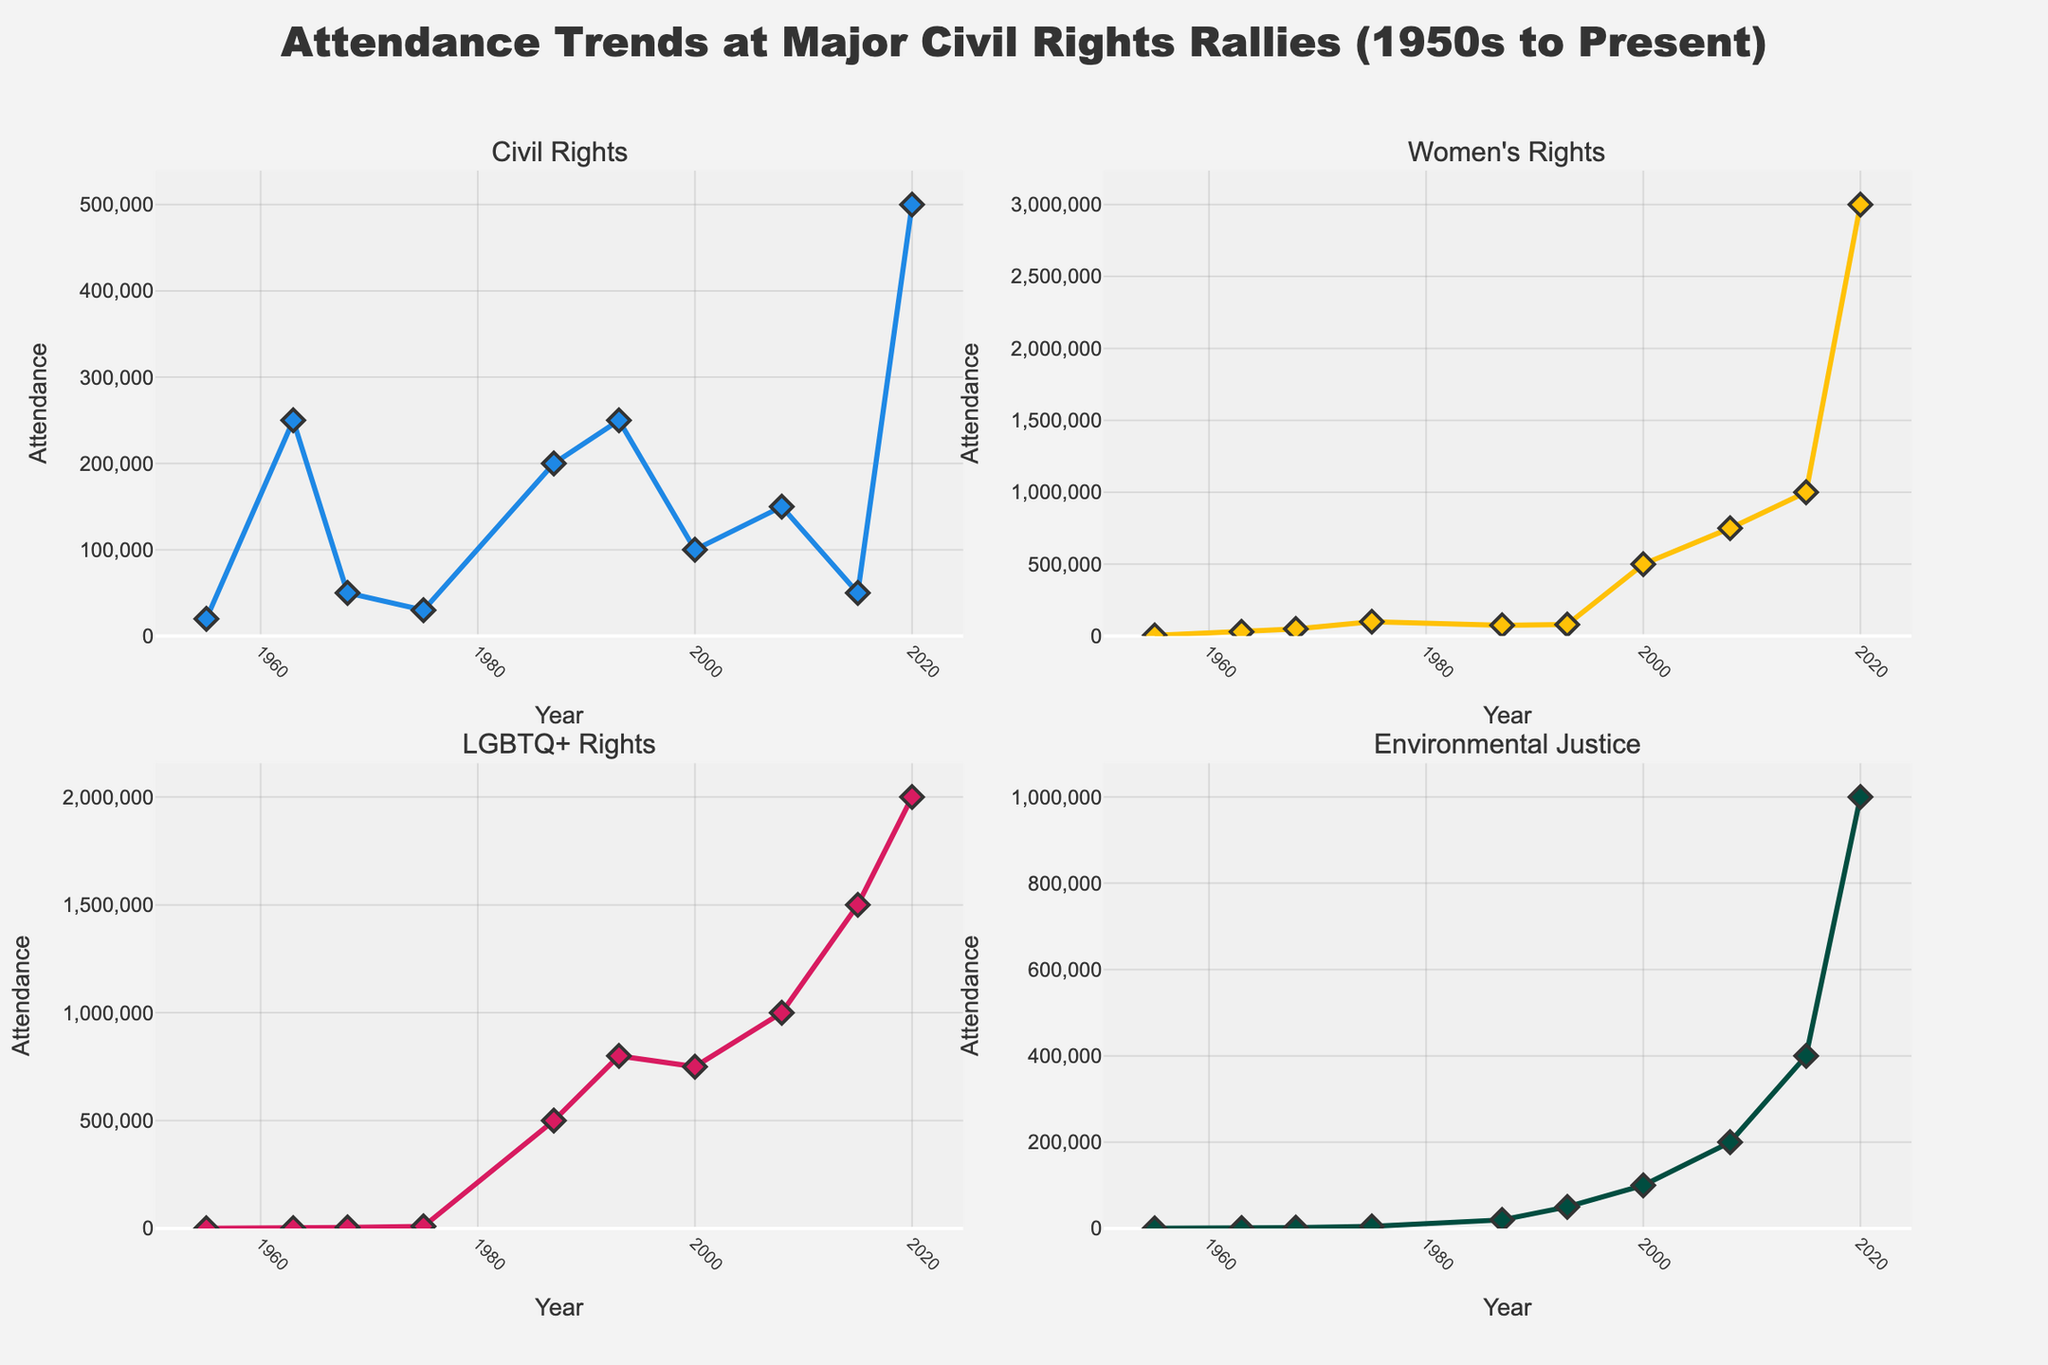How has the energy density of batteries evolved from 2010 to 2022? To answer this, look at the line plot in the first subplot titled 'Energy Density vs Time'. Observe the values on the y-axis for energy density (Wh/kg) and how they change along the x-axis (Year). From 2010 to 2022, energy density increases steadily from 100 Wh/kg to 220 Wh/kg.
Answer: It has increased from 100 Wh/kg to 220 Wh/kg What is the range improvement percentage in 2020 compared to 2010? Refer to the bar chart in the second subplot titled 'Range Improvement vs Time'. Notice the bar heights for the years 2010 and 2020. In 2010, the range improvement is 0%, and in 2020, it is 100%. Calculate the difference: 100% - 0% = 100%.
Answer: 100% Identify which year marks the introduction of solid-state lithium batteries. Use the scatter plot in the third subplot titled 'Battery Type Evolution'. Observe the years on the x-axis and look for the text label 'Solid-state Lithium'. It first appears in 2018.
Answer: 2018 Which electric vehicle model had the highest range in 2020? Look at the fourth subplot titled 'EV Range Comparison'. Identify the data points for the year 2020, and compare the range values for Tesla Model S, Rivian R1T, and Lucid Air. The highest value is 520 miles for Lucid Air.
Answer: Lucid Air Compare the change in range for the Tesla Model S from 2010 to 2022. In the 'EV Range Comparison' subplot, trace the line for Tesla Model S from the year 2010 to 2022. Note the values in 2010 (160 miles) and 2022 (405 miles). Calculate the difference: 405 - 160 = 245 miles.
Answer: 245 miles What was the energy density of silicon-based lithium-ion batteries in 2016? Refer to the 'Energy Density vs Time' line plot for the year 2016. Note the corresponding y-value, which is indicated at 160 Wh/kg.
Answer: 160 Wh/kg Which year experienced the highest single-year jump in range improvement percentage? Look at the 'Range Improvement vs Time' bar chart. Examine the heights of the bars and find the year with the largest increase from its previous year. Between 2016 (60%) and 2018 (80%), there is a 20% jump, the highest seen.
Answer: 2018 How did the range of the Tesla Model S change between 2018 and 2020? Check the 'EV Range Comparison' subplot. Note the range values for Tesla Model S in 2018 (370 miles) and 2020 (402 miles). Calculate the difference: 402 - 370 = 32 miles.
Answer: 32 miles What is the average energy density (Wh/kg) from 2010 to 2022? Find the 'Energy Density vs Time' plot and read the values: 100, 120, 140, 160, 180, 200, 220. Add them up: 100 + 120 + 140 + 160 + 180 + 200 + 220 = 1120. Divide by the number of points (7): 1120 / 7 ≈ 160 Wh/kg.
Answer: 160 Wh/kg Which battery types were in use in 2014 and 2022? Refer to the 'Battery Type Evolution' scatter plot, and find which types are labeled for 2014 (Lithium-ion NMC) and 2022 (Lithium-metal).
Answer: Lithium-ion NMC in 2014 and Lithium-metal in 2022 